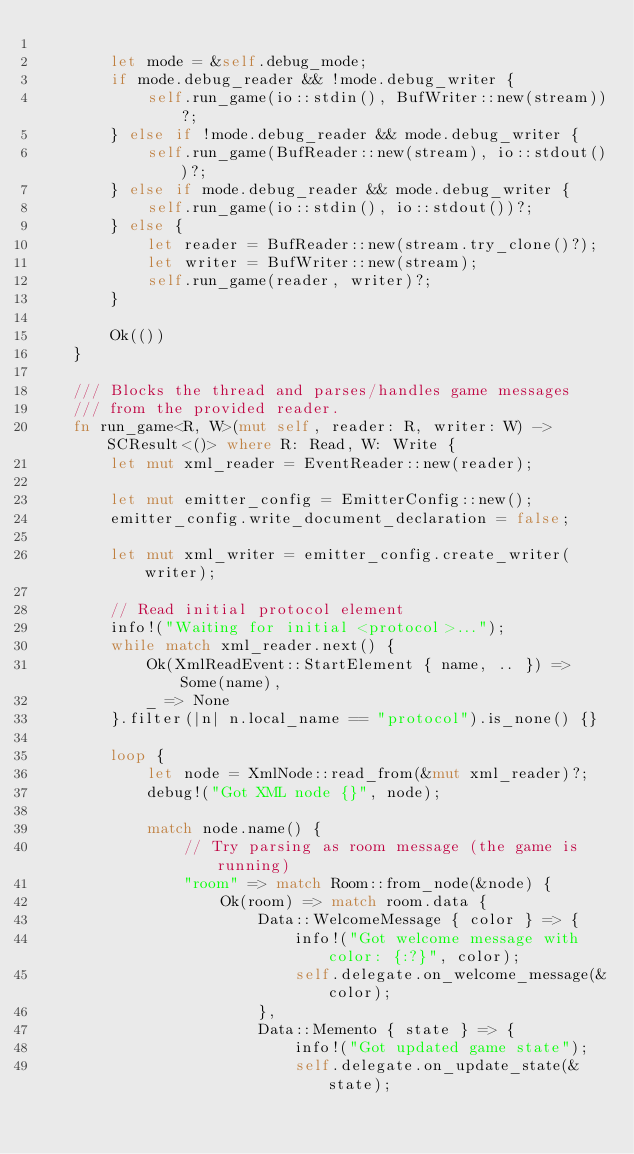<code> <loc_0><loc_0><loc_500><loc_500><_Rust_>
        let mode = &self.debug_mode;
        if mode.debug_reader && !mode.debug_writer {
            self.run_game(io::stdin(), BufWriter::new(stream))?;
        } else if !mode.debug_reader && mode.debug_writer {
            self.run_game(BufReader::new(stream), io::stdout())?;
        } else if mode.debug_reader && mode.debug_writer {
            self.run_game(io::stdin(), io::stdout())?;
        } else {
            let reader = BufReader::new(stream.try_clone()?);
            let writer = BufWriter::new(stream);
            self.run_game(reader, writer)?;
        }
        
        Ok(())
    }
    
    /// Blocks the thread and parses/handles game messages
    /// from the provided reader.
    fn run_game<R, W>(mut self, reader: R, writer: W) -> SCResult<()> where R: Read, W: Write {
        let mut xml_reader = EventReader::new(reader);

        let mut emitter_config = EmitterConfig::new();
        emitter_config.write_document_declaration = false;

        let mut xml_writer = emitter_config.create_writer(writer);
        
        // Read initial protocol element
        info!("Waiting for initial <protocol>...");
        while match xml_reader.next() {
            Ok(XmlReadEvent::StartElement { name, .. }) => Some(name),
            _ => None
        }.filter(|n| n.local_name == "protocol").is_none() {}

        loop {
            let node = XmlNode::read_from(&mut xml_reader)?;
            debug!("Got XML node {}", node);
            
            match node.name() {
                // Try parsing as room message (the game is running)
                "room" => match Room::from_node(&node) {
                    Ok(room) => match room.data {
                        Data::WelcomeMessage { color } => {
                            info!("Got welcome message with color: {:?}", color);
                            self.delegate.on_welcome_message(&color);
                        },
                        Data::Memento { state } => {
                            info!("Got updated game state");
                            self.delegate.on_update_state(&state);</code> 